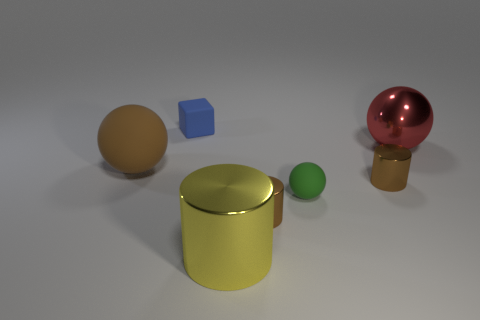Can you describe the shapes and colors of the objects in the image? Certainly! The image features a collection of geometric shapes showcasing five different objects. From left to right, there's a tan-colored sphere, a smaller blue cube, a sizable, gold-tinted metallic cylinder, a small lime-green sphere, and on the far right, a reflective pinkish-red sphere perched atop a golden cylindrical base. 